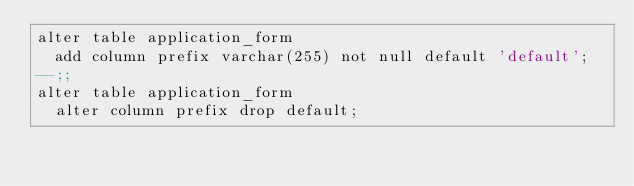<code> <loc_0><loc_0><loc_500><loc_500><_SQL_>alter table application_form
  add column prefix varchar(255) not null default 'default';
--;;
alter table application_form
  alter column prefix drop default;
</code> 